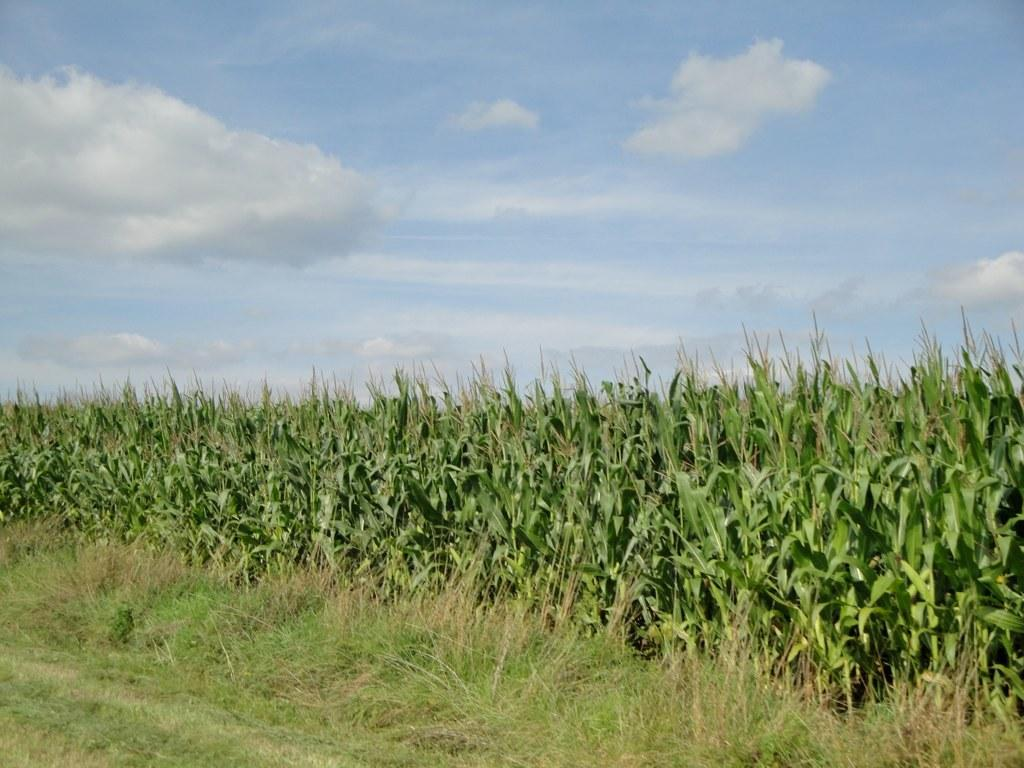What type of living organisms can be seen in the image? There is a group of plants in the image. What type of vegetation is visible in the image? There is grass visible in the image. What is visible at the top of the image? The sky is visible at the top of the image. How many boats are visible in the image? There are no boats present in the image. What is the process for increasing the size of the plants in the image? The image does not show any process for increasing the size of the plants, and it is not possible to determine this information from the image alone. 